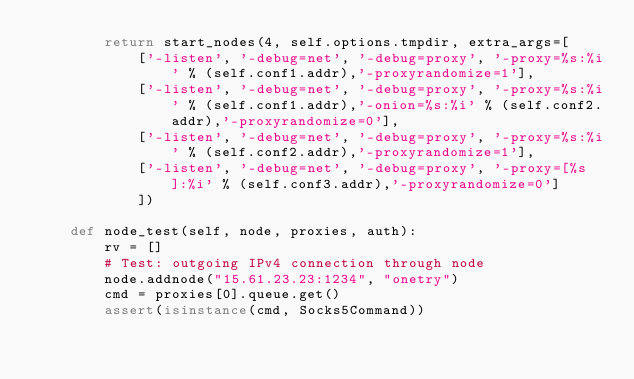Convert code to text. <code><loc_0><loc_0><loc_500><loc_500><_Python_>        return start_nodes(4, self.options.tmpdir, extra_args=[
            ['-listen', '-debug=net', '-debug=proxy', '-proxy=%s:%i' % (self.conf1.addr),'-proxyrandomize=1'],
            ['-listen', '-debug=net', '-debug=proxy', '-proxy=%s:%i' % (self.conf1.addr),'-onion=%s:%i' % (self.conf2.addr),'-proxyrandomize=0'],
            ['-listen', '-debug=net', '-debug=proxy', '-proxy=%s:%i' % (self.conf2.addr),'-proxyrandomize=1'],
            ['-listen', '-debug=net', '-debug=proxy', '-proxy=[%s]:%i' % (self.conf3.addr),'-proxyrandomize=0']
            ])

    def node_test(self, node, proxies, auth):
        rv = []
        # Test: outgoing IPv4 connection through node
        node.addnode("15.61.23.23:1234", "onetry")
        cmd = proxies[0].queue.get()
        assert(isinstance(cmd, Socks5Command))</code> 